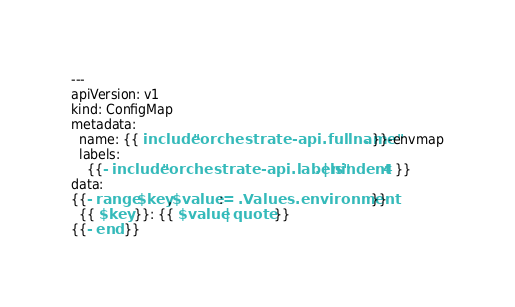Convert code to text. <code><loc_0><loc_0><loc_500><loc_500><_YAML_>---
apiVersion: v1
kind: ConfigMap
metadata:
  name: {{ include "orchestrate-api.fullname" . }}-envmap
  labels:
    {{- include "orchestrate-api.labels" . | nindent 4 }}
data:
{{- range $key,$value := .Values.environment }}
  {{ $key }}: {{ $value | quote }}
{{- end }}
</code> 